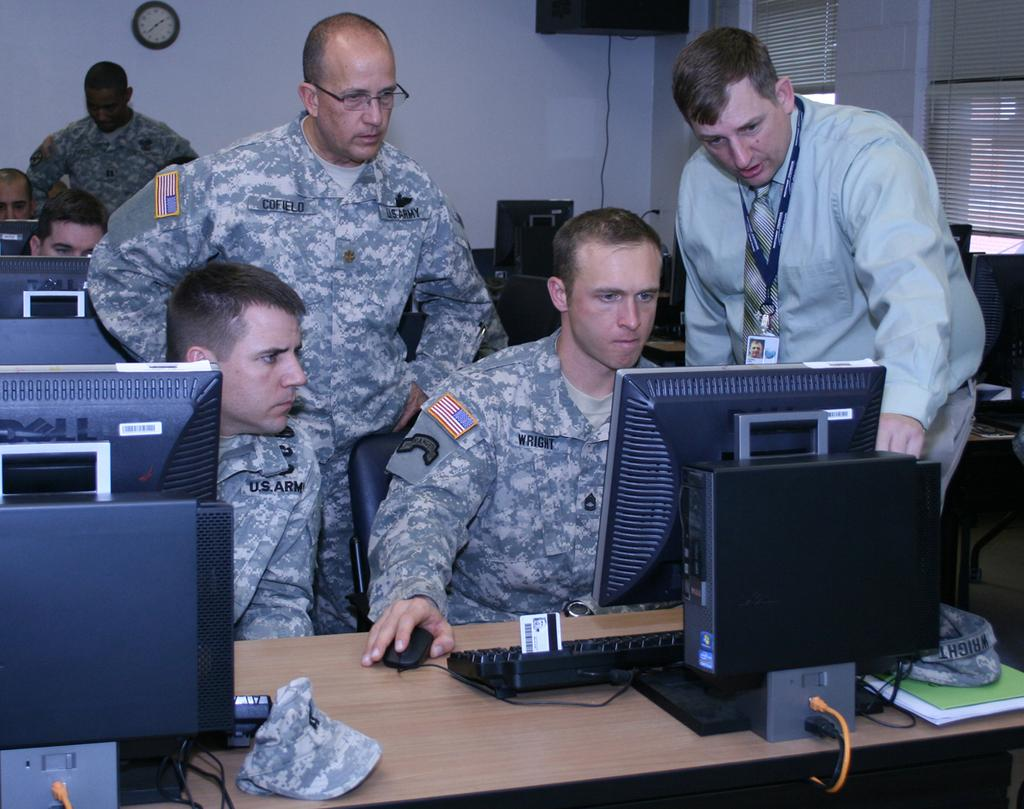<image>
Write a terse but informative summary of the picture. Four army men are looking at a computer and the nearest has Wright printed on his uniform. 